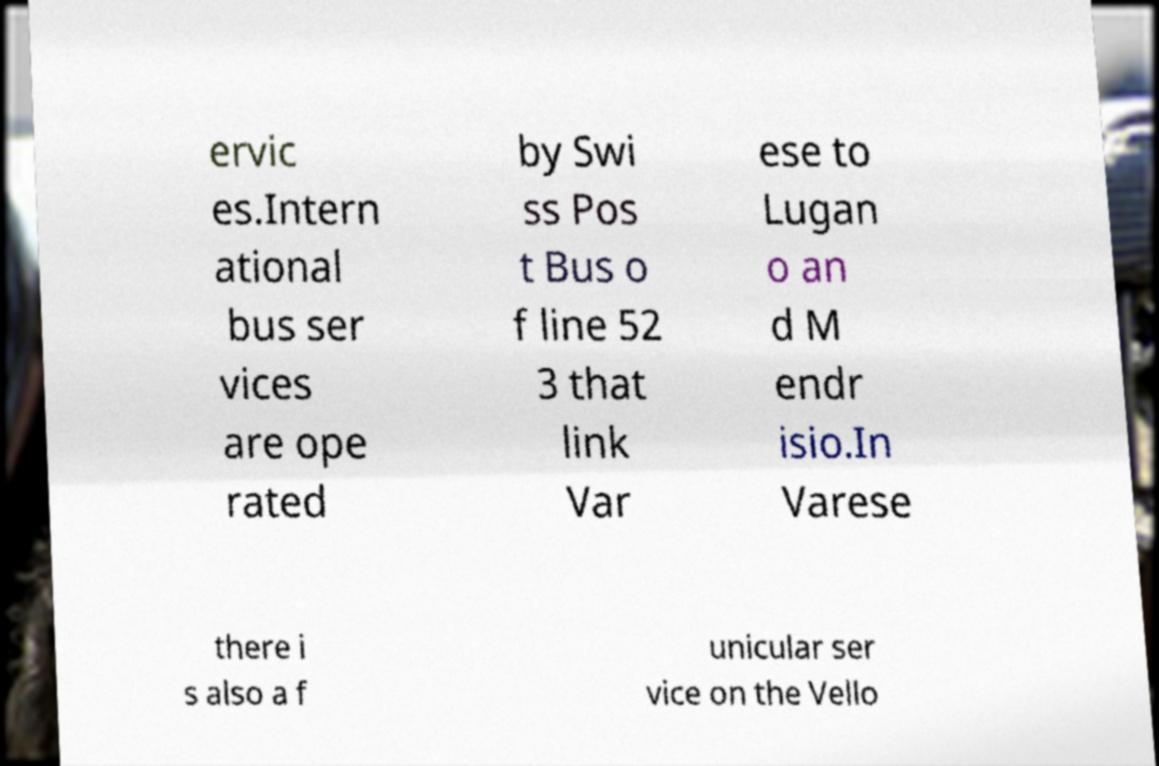There's text embedded in this image that I need extracted. Can you transcribe it verbatim? ervic es.Intern ational bus ser vices are ope rated by Swi ss Pos t Bus o f line 52 3 that link Var ese to Lugan o an d M endr isio.In Varese there i s also a f unicular ser vice on the Vello 